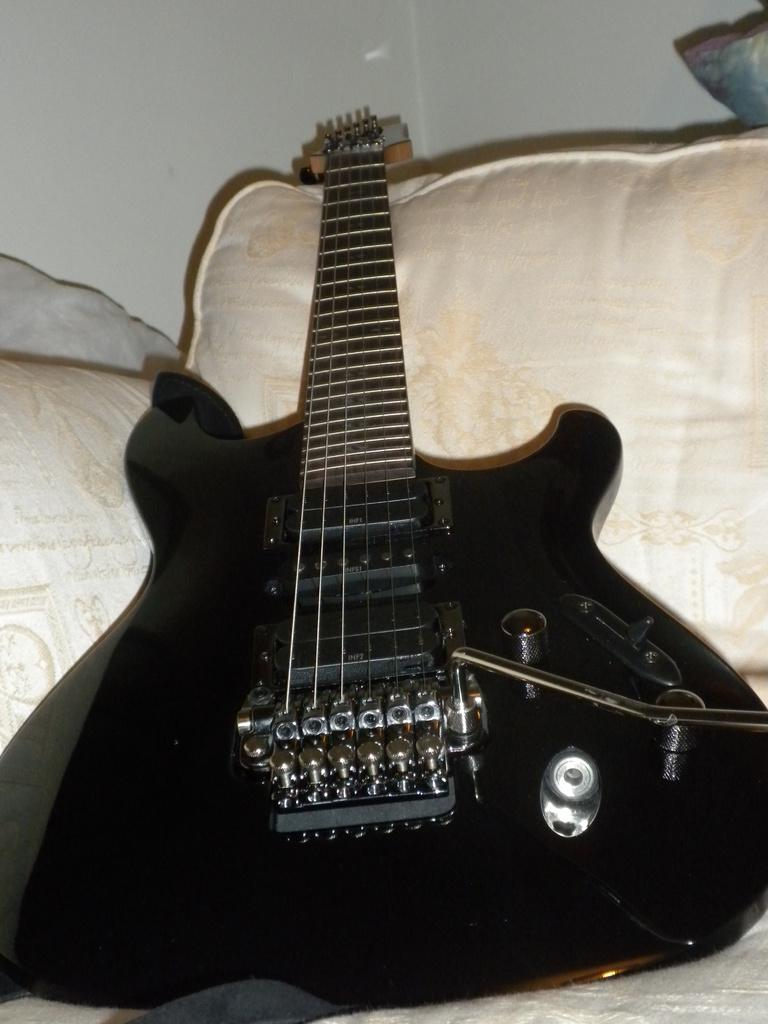What musical instrument is present in the image? There is a guitar in the image. What type of furniture is visible in the image? There is a bed in the image. What can be found on the bed in the image? There are pillows on the bed in the image. What type of letter is being written on the guitar in the image? There is no letter or writing present on the guitar in the image. 